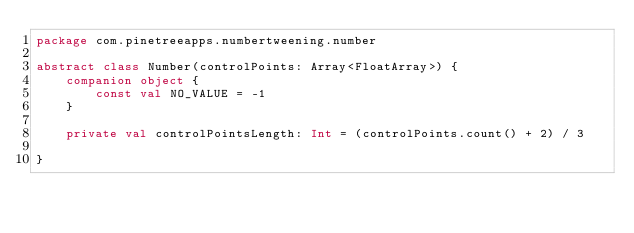Convert code to text. <code><loc_0><loc_0><loc_500><loc_500><_Kotlin_>package com.pinetreeapps.numbertweening.number

abstract class Number(controlPoints: Array<FloatArray>) {
    companion object {
        const val NO_VALUE = -1
    }

    private val controlPointsLength: Int = (controlPoints.count() + 2) / 3

}</code> 